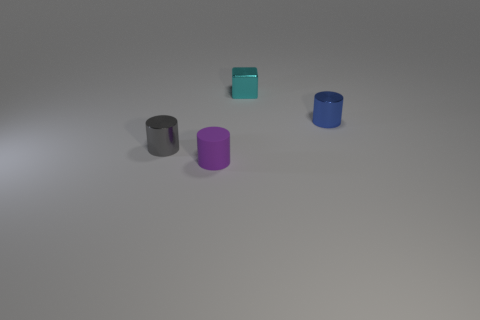What number of purple cylinders are on the right side of the small metallic block?
Keep it short and to the point. 0. What number of tiny metallic cylinders are both in front of the blue thing and to the right of the small cyan object?
Keep it short and to the point. 0. There is a tiny gray object that is made of the same material as the cyan block; what is its shape?
Offer a very short reply. Cylinder. Does the shiny cylinder that is on the left side of the matte object have the same size as the shiny object right of the cyan object?
Your response must be concise. Yes. There is a thing left of the small rubber object; what is its color?
Give a very brief answer. Gray. The object that is behind the metallic cylinder behind the tiny gray shiny object is made of what material?
Ensure brevity in your answer.  Metal. What shape is the small blue object?
Offer a terse response. Cylinder. What is the material of the blue thing that is the same shape as the small gray metal thing?
Offer a very short reply. Metal. How many gray shiny objects are the same size as the cyan metallic cube?
Your response must be concise. 1. There is a small thing behind the blue shiny cylinder; are there any small cyan metallic things right of it?
Ensure brevity in your answer.  No. 